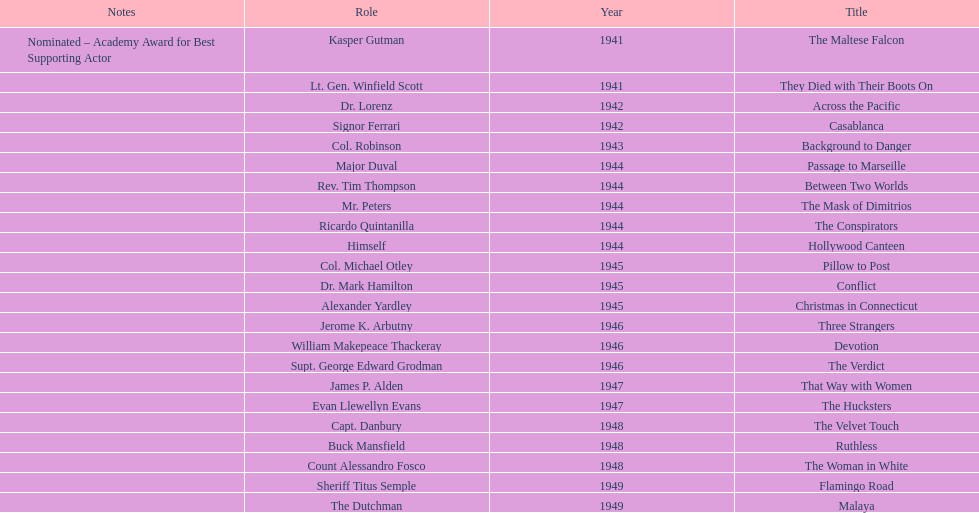What are the movies? The Maltese Falcon, They Died with Their Boots On, Across the Pacific, Casablanca, Background to Danger, Passage to Marseille, Between Two Worlds, The Mask of Dimitrios, The Conspirators, Hollywood Canteen, Pillow to Post, Conflict, Christmas in Connecticut, Three Strangers, Devotion, The Verdict, That Way with Women, The Hucksters, The Velvet Touch, Ruthless, The Woman in White, Flamingo Road, Malaya. Of these, for which did he get nominated for an oscar? The Maltese Falcon. 